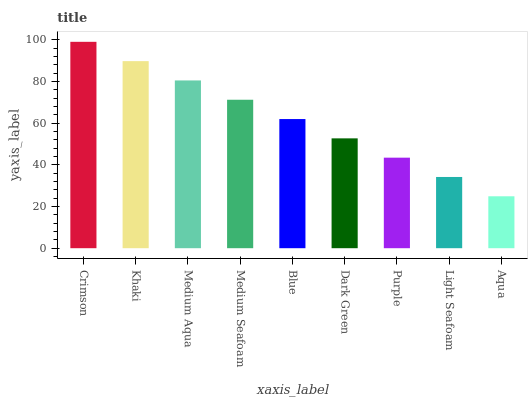Is Aqua the minimum?
Answer yes or no. Yes. Is Crimson the maximum?
Answer yes or no. Yes. Is Khaki the minimum?
Answer yes or no. No. Is Khaki the maximum?
Answer yes or no. No. Is Crimson greater than Khaki?
Answer yes or no. Yes. Is Khaki less than Crimson?
Answer yes or no. Yes. Is Khaki greater than Crimson?
Answer yes or no. No. Is Crimson less than Khaki?
Answer yes or no. No. Is Blue the high median?
Answer yes or no. Yes. Is Blue the low median?
Answer yes or no. Yes. Is Light Seafoam the high median?
Answer yes or no. No. Is Dark Green the low median?
Answer yes or no. No. 